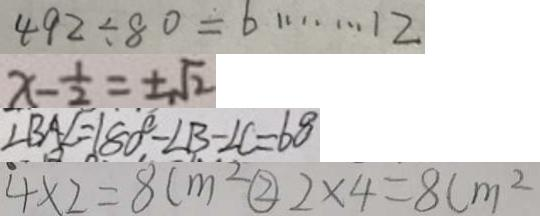Convert formula to latex. <formula><loc_0><loc_0><loc_500><loc_500>4 9 2 \div 8 0 = 6 \cdots 1 2 
 x - \frac { 1 } { 2 } = \pm \sqrt { 2 } 
 \angle B A E = 1 8 0 ^ { \circ } - \angle B - \angle C = 6 0 ^ { \circ } 
 4 \times 2 = 8 c m ^ { 2 } \textcircled { 2 } 2 \times 4 = 8 c m ^ { 2 }</formula> 